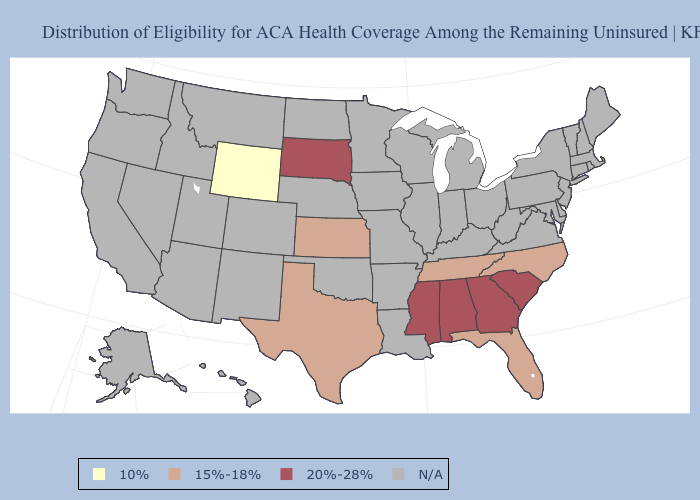What is the lowest value in the West?
Give a very brief answer. 10%. What is the value of Tennessee?
Quick response, please. 15%-18%. Does the first symbol in the legend represent the smallest category?
Keep it brief. Yes. What is the lowest value in the West?
Give a very brief answer. 10%. Does the first symbol in the legend represent the smallest category?
Quick response, please. Yes. What is the value of Georgia?
Keep it brief. 20%-28%. 